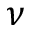<formula> <loc_0><loc_0><loc_500><loc_500>\nu</formula> 